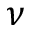<formula> <loc_0><loc_0><loc_500><loc_500>\nu</formula> 